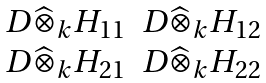<formula> <loc_0><loc_0><loc_500><loc_500>\begin{matrix} D \widehat { \otimes } _ { k } H _ { 1 1 } & D \widehat { \otimes } _ { k } H _ { 1 2 } \\ D \widehat { \otimes } _ { k } H _ { 2 1 } & D \widehat { \otimes } _ { k } H _ { 2 2 } \end{matrix}</formula> 